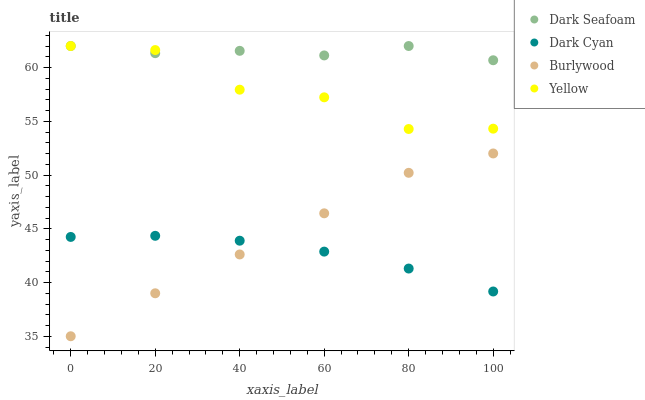Does Dark Cyan have the minimum area under the curve?
Answer yes or no. Yes. Does Dark Seafoam have the maximum area under the curve?
Answer yes or no. Yes. Does Burlywood have the minimum area under the curve?
Answer yes or no. No. Does Burlywood have the maximum area under the curve?
Answer yes or no. No. Is Dark Cyan the smoothest?
Answer yes or no. Yes. Is Yellow the roughest?
Answer yes or no. Yes. Is Burlywood the smoothest?
Answer yes or no. No. Is Burlywood the roughest?
Answer yes or no. No. Does Burlywood have the lowest value?
Answer yes or no. Yes. Does Dark Seafoam have the lowest value?
Answer yes or no. No. Does Yellow have the highest value?
Answer yes or no. Yes. Does Burlywood have the highest value?
Answer yes or no. No. Is Burlywood less than Dark Seafoam?
Answer yes or no. Yes. Is Yellow greater than Burlywood?
Answer yes or no. Yes. Does Dark Cyan intersect Burlywood?
Answer yes or no. Yes. Is Dark Cyan less than Burlywood?
Answer yes or no. No. Is Dark Cyan greater than Burlywood?
Answer yes or no. No. Does Burlywood intersect Dark Seafoam?
Answer yes or no. No. 